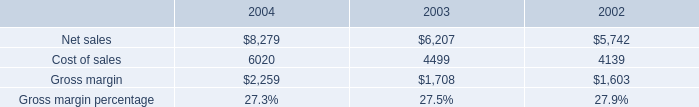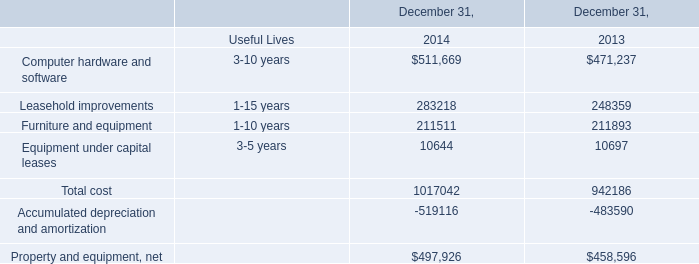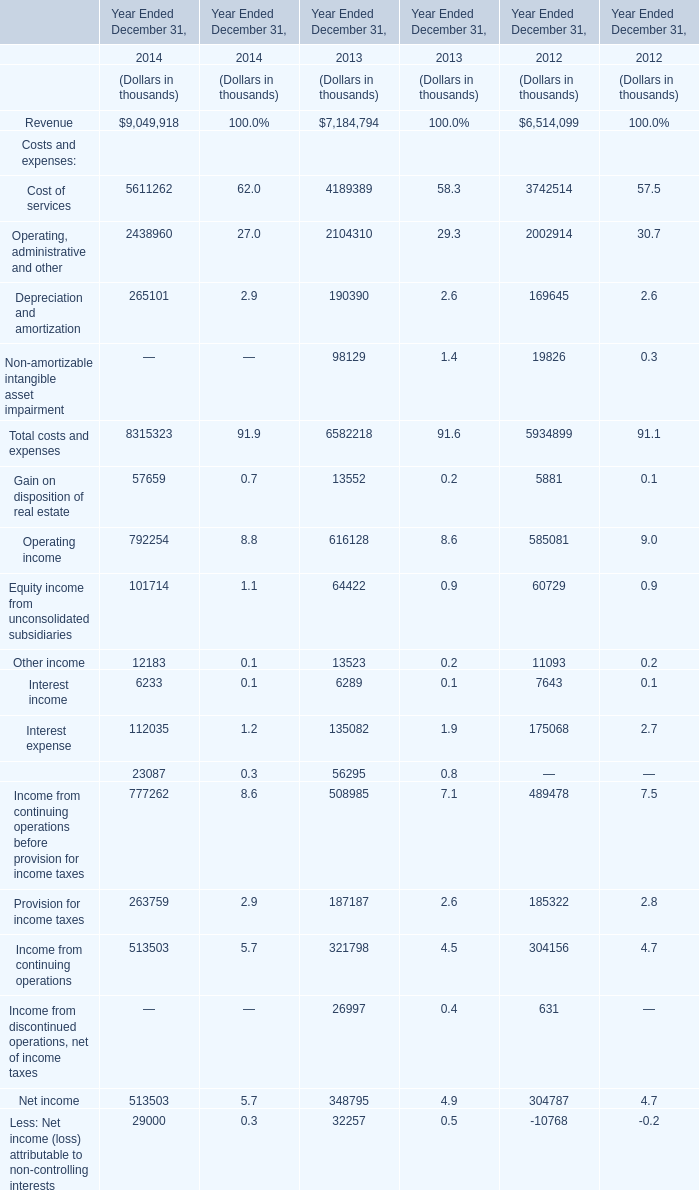What's the sum of Net sales of 2003, and Furniture and equipment of December 31, 2014 ? 
Computations: (6207.0 + 211511.0)
Answer: 217718.0. 